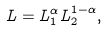<formula> <loc_0><loc_0><loc_500><loc_500>L = L _ { 1 } ^ { \alpha } L _ { 2 } ^ { 1 - \alpha } ,</formula> 